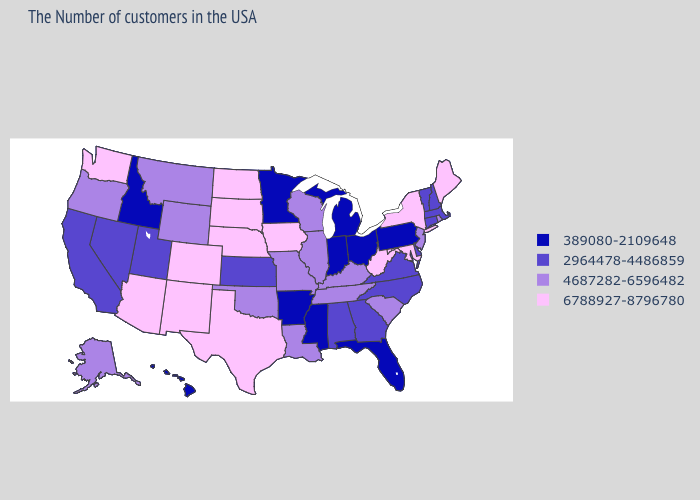What is the value of New Hampshire?
Keep it brief. 2964478-4486859. What is the lowest value in the MidWest?
Quick response, please. 389080-2109648. What is the value of Minnesota?
Short answer required. 389080-2109648. Among the states that border Vermont , which have the highest value?
Keep it brief. New York. Does Nevada have the lowest value in the USA?
Answer briefly. No. Name the states that have a value in the range 4687282-6596482?
Quick response, please. Rhode Island, New Jersey, South Carolina, Kentucky, Tennessee, Wisconsin, Illinois, Louisiana, Missouri, Oklahoma, Wyoming, Montana, Oregon, Alaska. Is the legend a continuous bar?
Write a very short answer. No. What is the value of Maine?
Write a very short answer. 6788927-8796780. Name the states that have a value in the range 2964478-4486859?
Be succinct. Massachusetts, New Hampshire, Vermont, Connecticut, Delaware, Virginia, North Carolina, Georgia, Alabama, Kansas, Utah, Nevada, California. What is the highest value in states that border Michigan?
Give a very brief answer. 4687282-6596482. What is the lowest value in the MidWest?
Concise answer only. 389080-2109648. Does New Jersey have the highest value in the USA?
Keep it brief. No. What is the highest value in states that border Colorado?
Be succinct. 6788927-8796780. Which states hav the highest value in the MidWest?
Concise answer only. Iowa, Nebraska, South Dakota, North Dakota. Which states hav the highest value in the West?
Quick response, please. Colorado, New Mexico, Arizona, Washington. 